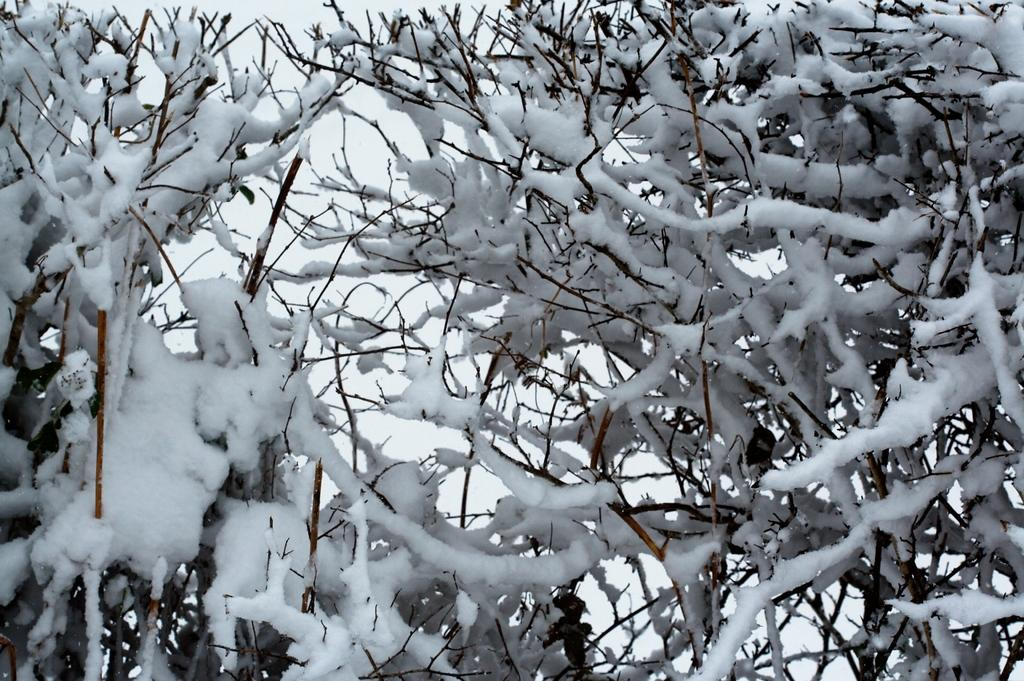What type of plant is in the image? There is a dried plant in the image. What is the condition of the plant? The plant has ice on it. What can be seen in the background of the image? The sky is visible in the background of the image. What color is the horse's shirt in the image? There is no horse or shirt present in the image. 